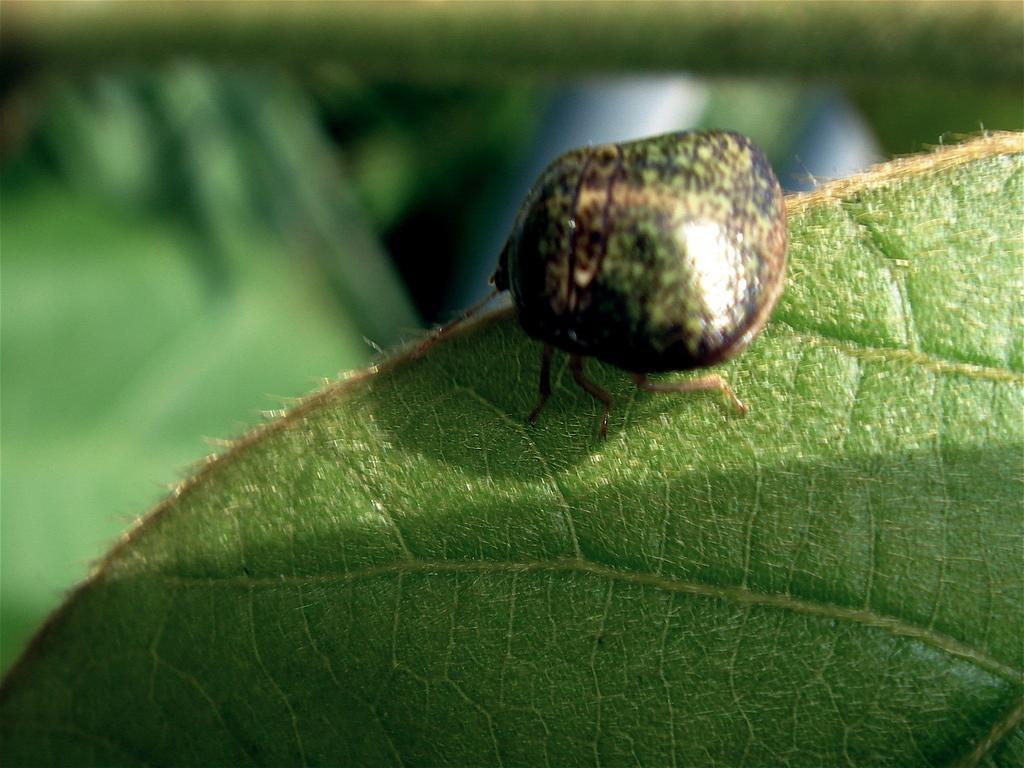Please provide a concise description of this image. In this image there is a green leaf on which there is a insect. 